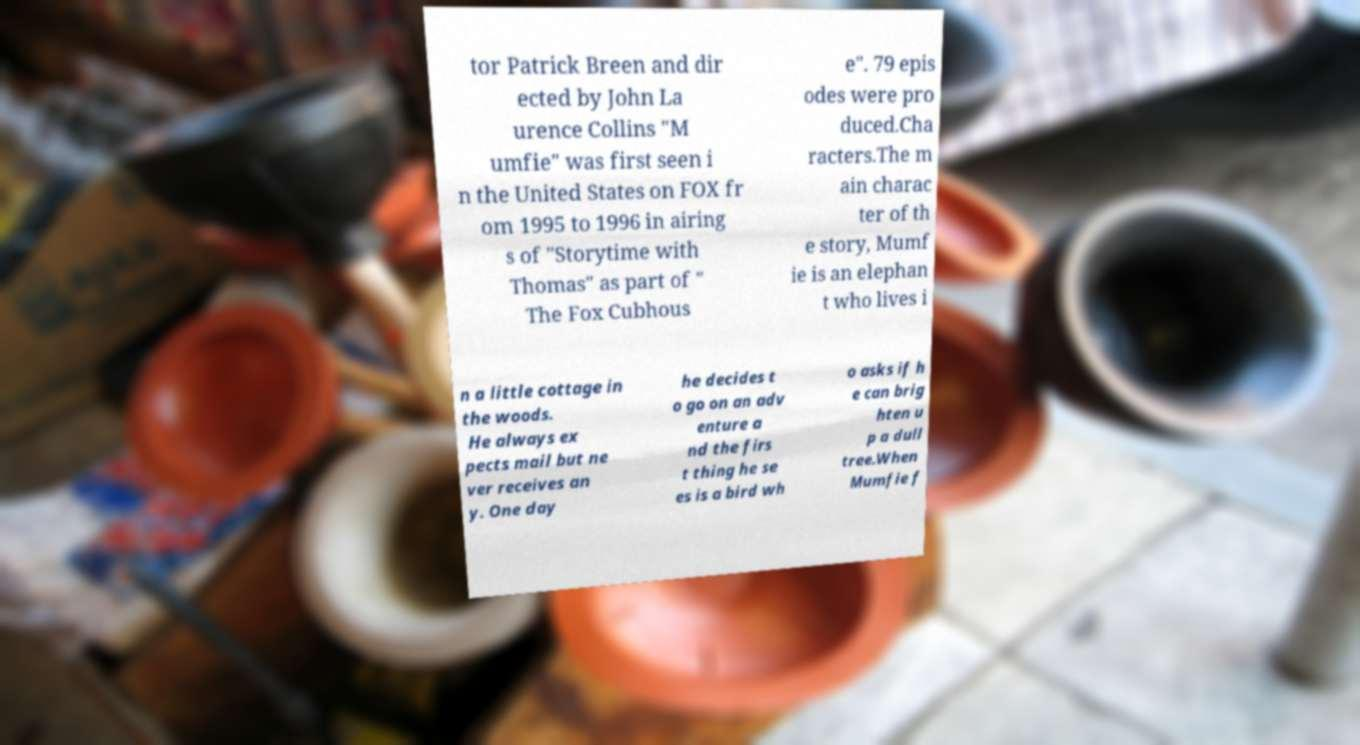Could you assist in decoding the text presented in this image and type it out clearly? tor Patrick Breen and dir ected by John La urence Collins "M umfie" was first seen i n the United States on FOX fr om 1995 to 1996 in airing s of "Storytime with Thomas" as part of " The Fox Cubhous e". 79 epis odes were pro duced.Cha racters.The m ain charac ter of th e story, Mumf ie is an elephan t who lives i n a little cottage in the woods. He always ex pects mail but ne ver receives an y. One day he decides t o go on an adv enture a nd the firs t thing he se es is a bird wh o asks if h e can brig hten u p a dull tree.When Mumfie f 